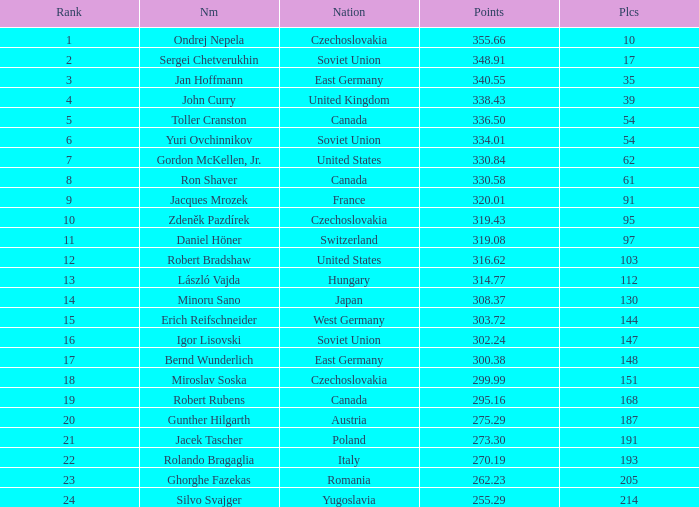Which Placings have a Nation of west germany, and Points larger than 303.72? None. 